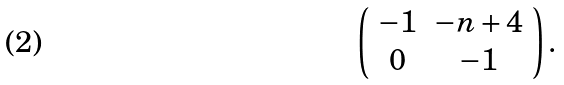Convert formula to latex. <formula><loc_0><loc_0><loc_500><loc_500>\left ( \begin{array} { c c } - 1 & - n + 4 \\ 0 & - 1 \end{array} \right ) .</formula> 